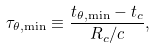Convert formula to latex. <formula><loc_0><loc_0><loc_500><loc_500>\tau _ { \theta , \min } \equiv \frac { t _ { \theta , \min } - t _ { c } } { R _ { c } / c } ,</formula> 